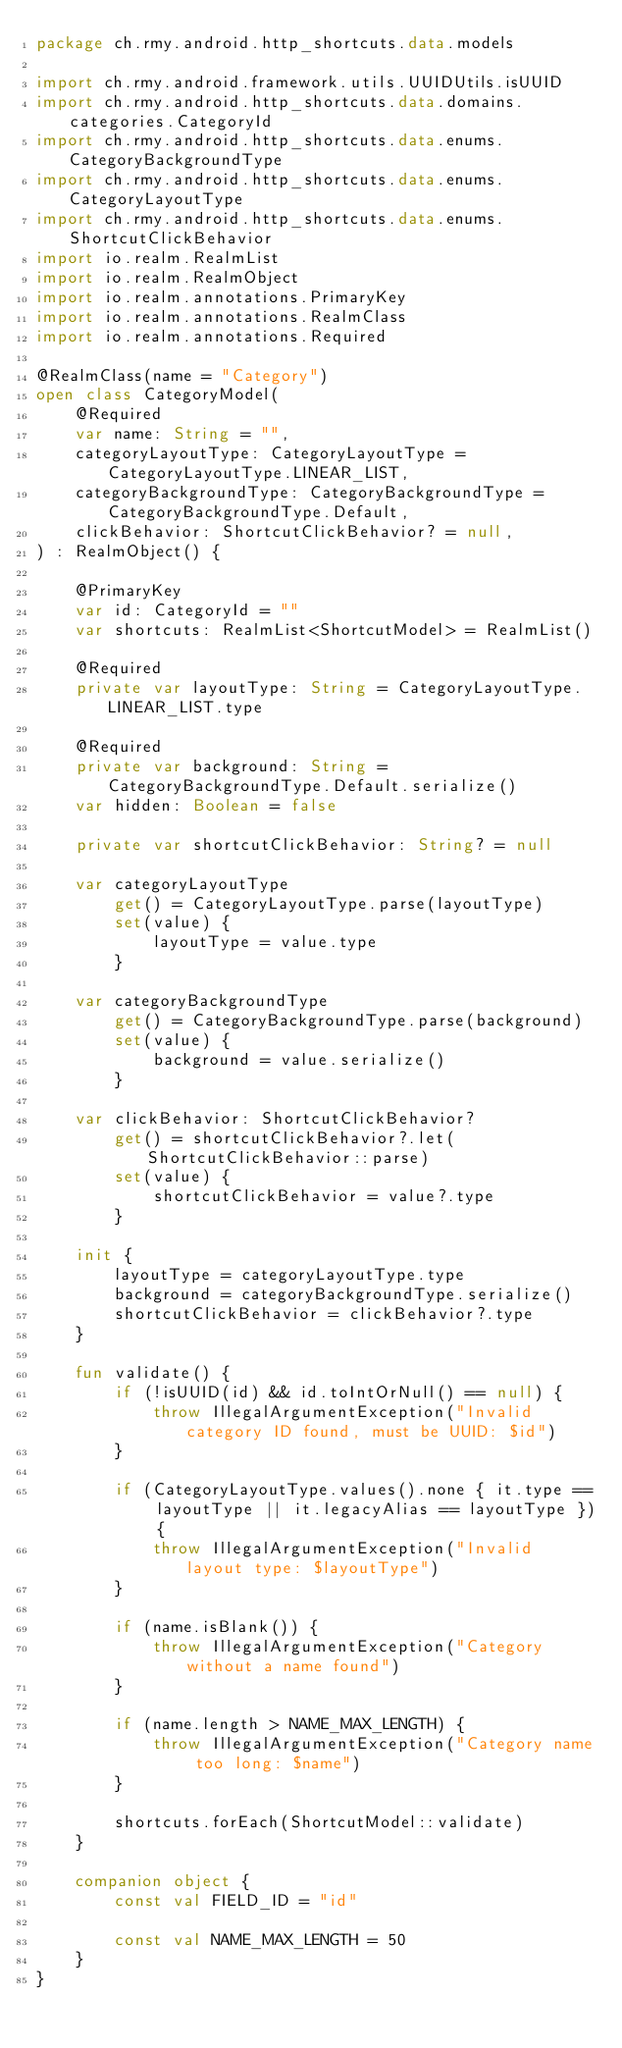Convert code to text. <code><loc_0><loc_0><loc_500><loc_500><_Kotlin_>package ch.rmy.android.http_shortcuts.data.models

import ch.rmy.android.framework.utils.UUIDUtils.isUUID
import ch.rmy.android.http_shortcuts.data.domains.categories.CategoryId
import ch.rmy.android.http_shortcuts.data.enums.CategoryBackgroundType
import ch.rmy.android.http_shortcuts.data.enums.CategoryLayoutType
import ch.rmy.android.http_shortcuts.data.enums.ShortcutClickBehavior
import io.realm.RealmList
import io.realm.RealmObject
import io.realm.annotations.PrimaryKey
import io.realm.annotations.RealmClass
import io.realm.annotations.Required

@RealmClass(name = "Category")
open class CategoryModel(
    @Required
    var name: String = "",
    categoryLayoutType: CategoryLayoutType = CategoryLayoutType.LINEAR_LIST,
    categoryBackgroundType: CategoryBackgroundType = CategoryBackgroundType.Default,
    clickBehavior: ShortcutClickBehavior? = null,
) : RealmObject() {

    @PrimaryKey
    var id: CategoryId = ""
    var shortcuts: RealmList<ShortcutModel> = RealmList()

    @Required
    private var layoutType: String = CategoryLayoutType.LINEAR_LIST.type

    @Required
    private var background: String = CategoryBackgroundType.Default.serialize()
    var hidden: Boolean = false

    private var shortcutClickBehavior: String? = null

    var categoryLayoutType
        get() = CategoryLayoutType.parse(layoutType)
        set(value) {
            layoutType = value.type
        }

    var categoryBackgroundType
        get() = CategoryBackgroundType.parse(background)
        set(value) {
            background = value.serialize()
        }

    var clickBehavior: ShortcutClickBehavior?
        get() = shortcutClickBehavior?.let(ShortcutClickBehavior::parse)
        set(value) {
            shortcutClickBehavior = value?.type
        }

    init {
        layoutType = categoryLayoutType.type
        background = categoryBackgroundType.serialize()
        shortcutClickBehavior = clickBehavior?.type
    }

    fun validate() {
        if (!isUUID(id) && id.toIntOrNull() == null) {
            throw IllegalArgumentException("Invalid category ID found, must be UUID: $id")
        }

        if (CategoryLayoutType.values().none { it.type == layoutType || it.legacyAlias == layoutType }) {
            throw IllegalArgumentException("Invalid layout type: $layoutType")
        }

        if (name.isBlank()) {
            throw IllegalArgumentException("Category without a name found")
        }

        if (name.length > NAME_MAX_LENGTH) {
            throw IllegalArgumentException("Category name too long: $name")
        }

        shortcuts.forEach(ShortcutModel::validate)
    }

    companion object {
        const val FIELD_ID = "id"

        const val NAME_MAX_LENGTH = 50
    }
}
</code> 